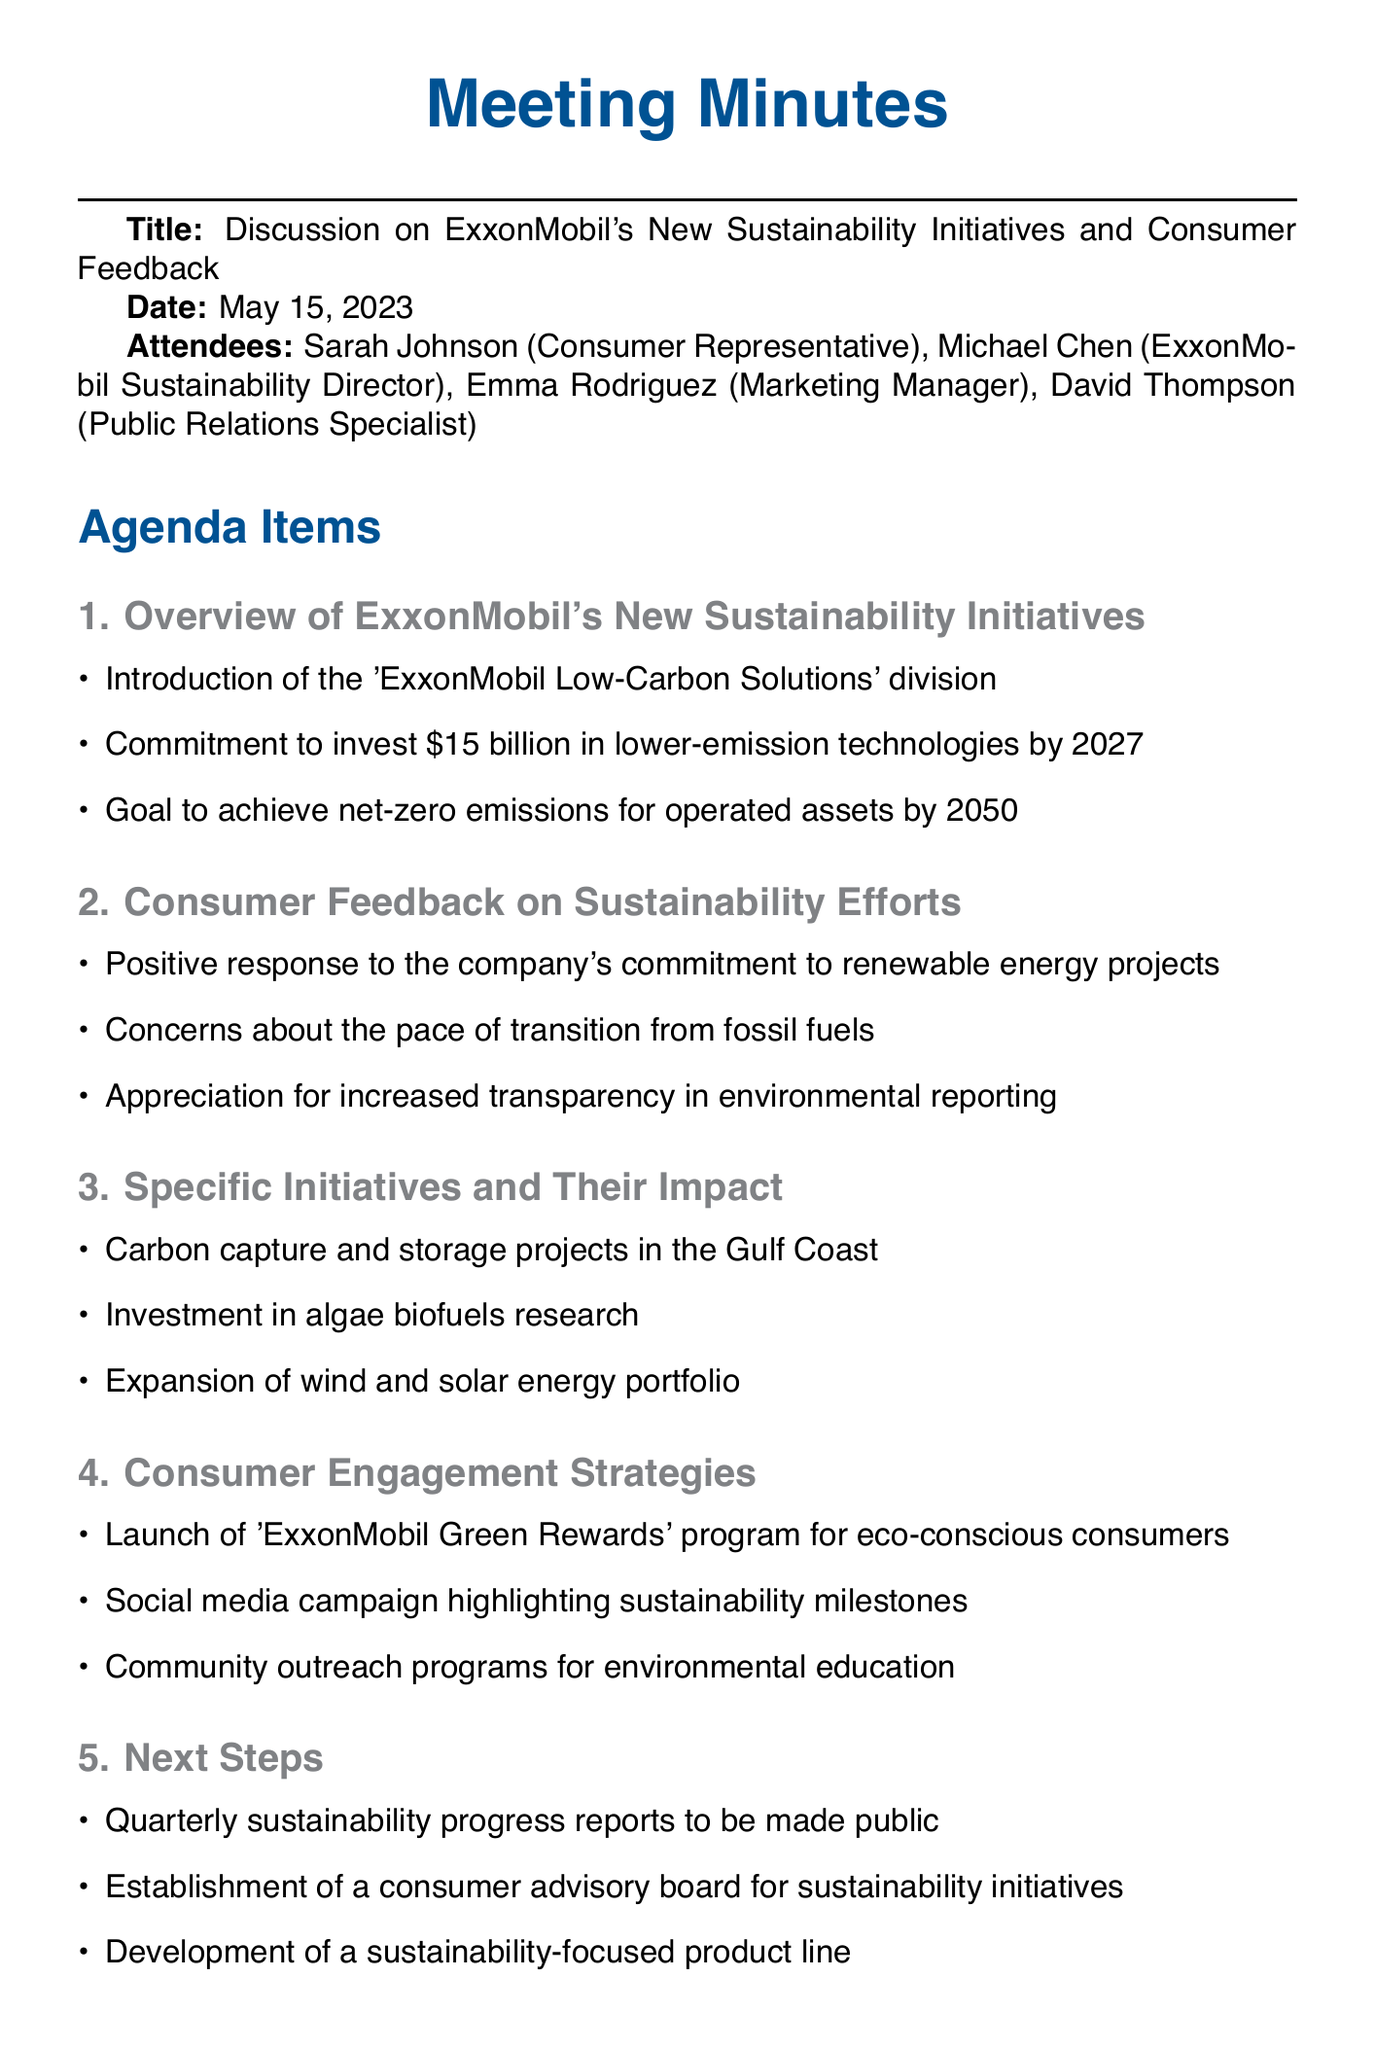What is the title of the meeting? The title of the meeting is specified at the beginning of the document.
Answer: Discussion on ExxonMobil's New Sustainability Initiatives and Consumer Feedback When was the meeting held? The date of the meeting is mentioned in the document.
Answer: May 15, 2023 Who is the ExxonMobil Sustainability Director? The document lists the attendees, including their roles.
Answer: Michael Chen What is ExxonMobil's investment commitment by 2027? The meeting agenda covers the company's specific financial goals.
Answer: $15 billion What is the goal for net-zero emissions? This goal is directly stated in the overview of the initiatives.
Answer: 2050 What program was launched for eco-conscious consumers? The specific consumer engagement strategy is highlighted in the document.
Answer: ExxonMobil Green Rewards What type of projects are being pursued at the Gulf Coast? The initiatives and their impacts are detailed in that section.
Answer: Carbon capture and storage projects What are the next steps regarding sustainability reports? The document outlines a specific frequency for the reports.
Answer: Quarterly Which team is responsible for developing materials on sustainability initiatives? The action items include responsibilities assigned to different teams.
Answer: Marketing team How will consumer engagement strategies be communicated? The action items specify preparations made by a particular team.
Answer: Press release 